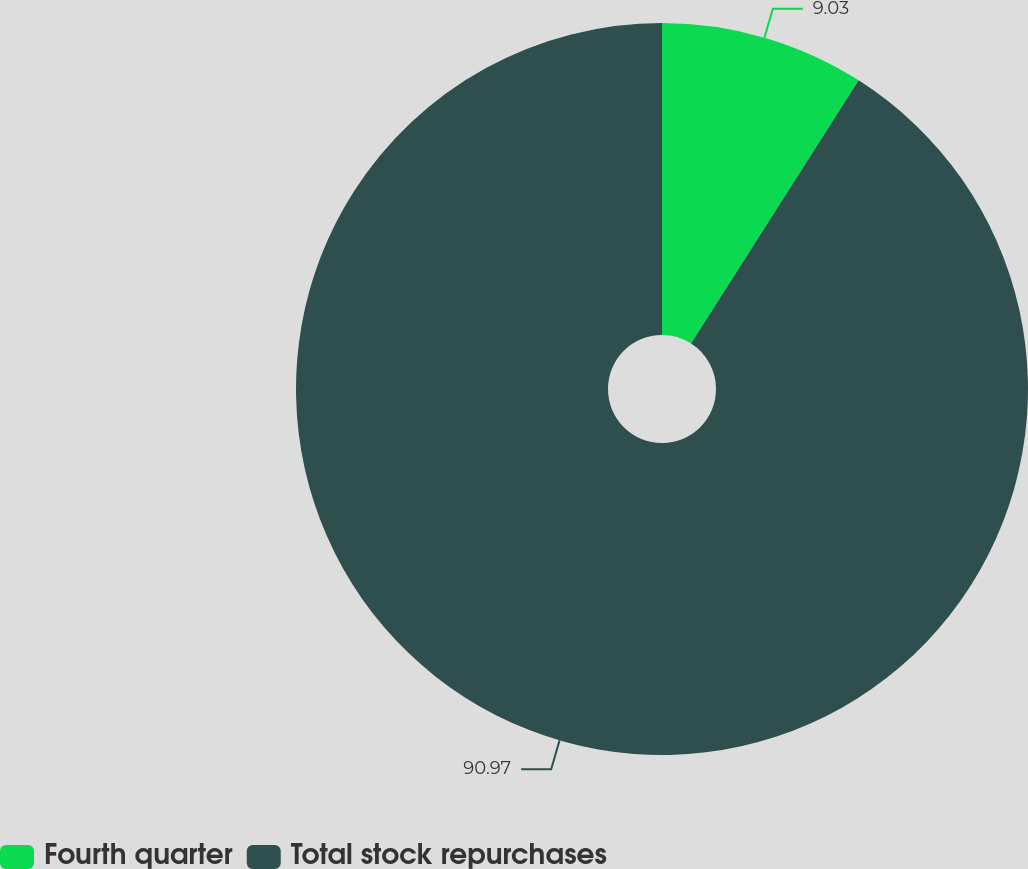Convert chart to OTSL. <chart><loc_0><loc_0><loc_500><loc_500><pie_chart><fcel>Fourth quarter<fcel>Total stock repurchases<nl><fcel>9.03%<fcel>90.97%<nl></chart> 